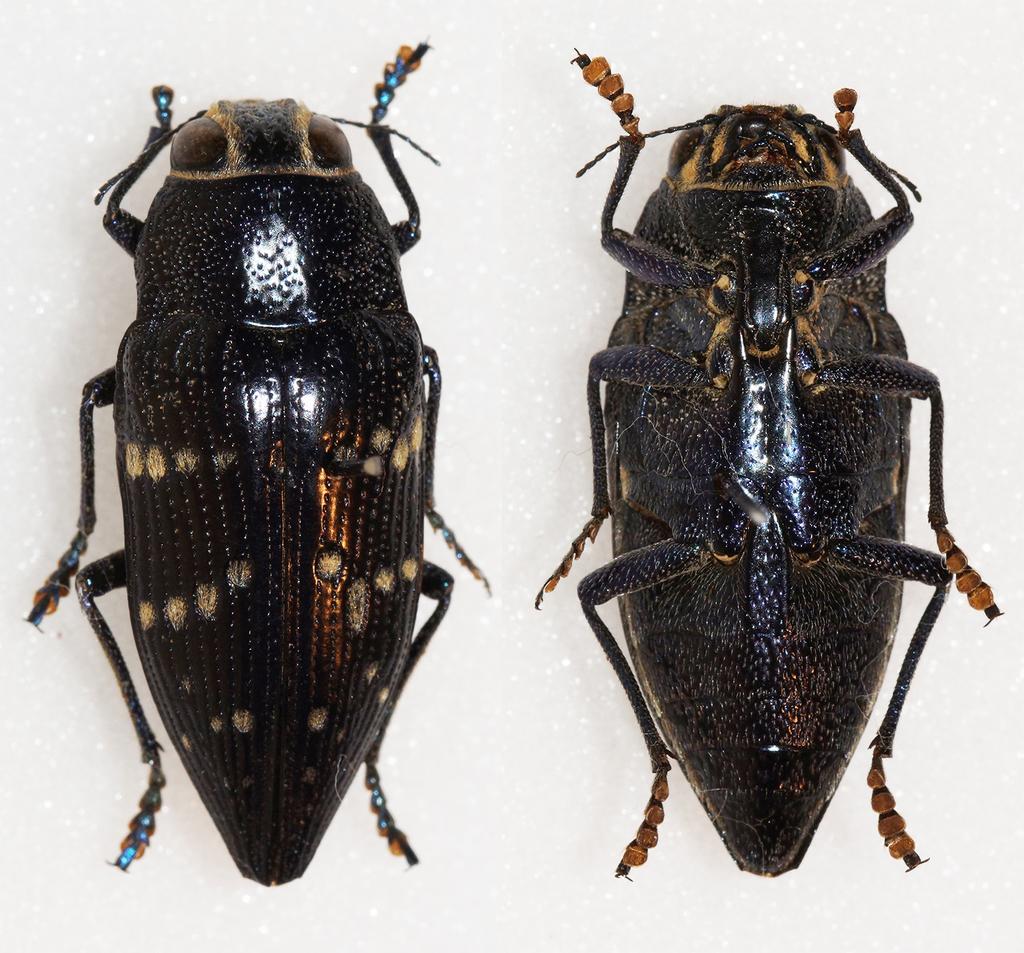Describe this image in one or two sentences. In this picture we can see two insects on the white surface. 